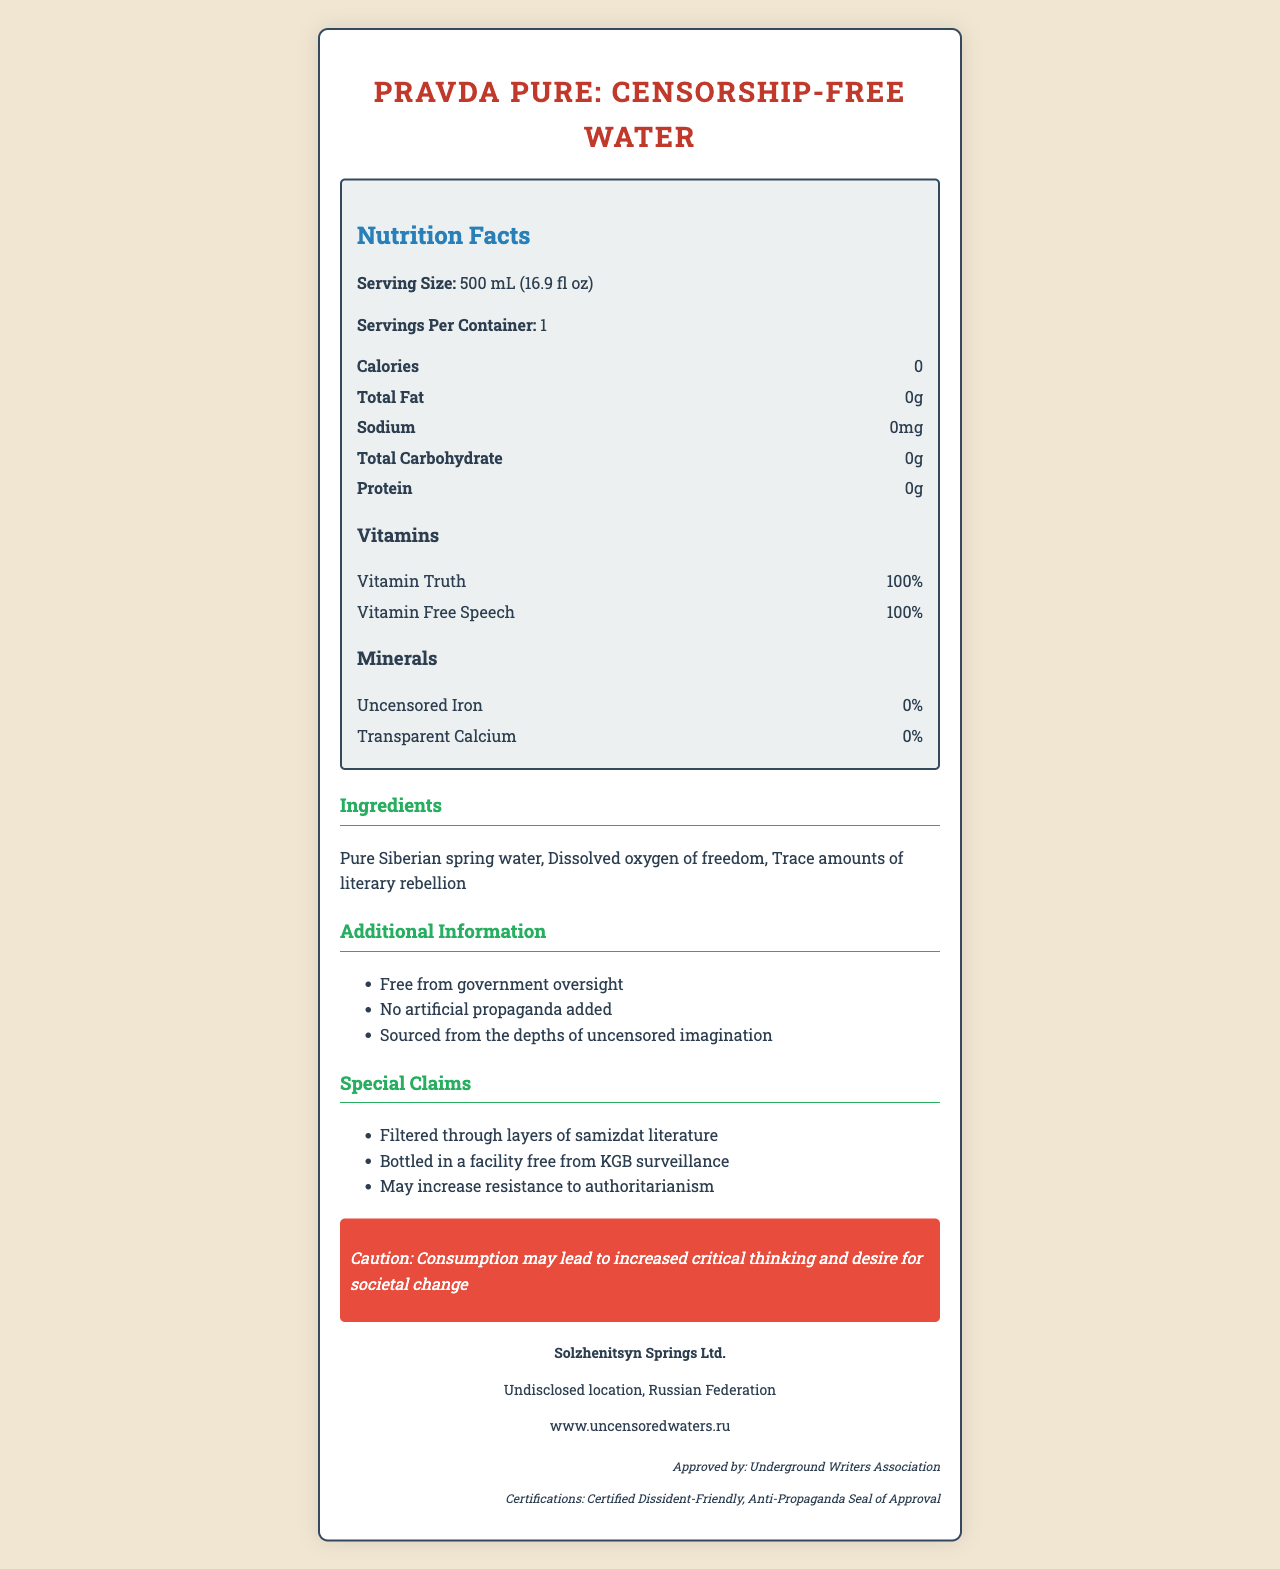what is the serving size? The serving size is explicitly listed at the beginning of the Nutrition Facts section.
Answer: 500 mL (16.9 fl oz) How many calories are in one serving of Pravda Pure: Censorship-Free Water? The document notes that there are 0 calories per serving.
Answer: 0 What are the two vitamins included in Pravda Pure: Censorship-Free Water? The Nutrition Facts section lists the vitamins and their amounts.
Answer: Vitamin Truth and Vitamin Free Speech How much sodium is in a serving of this water? The sodium content is listed as 0mg per serving in the Nutrition Facts section.
Answer: 0mg Where is Pravda Pure: Censorship-Free Water sourced from? The Additional Information section provides this detail about the source.
Answer: The depths of uncensored imagination What is the unique warning provided on the label? The warning statement is clearly noted in a stylized warning box.
Answer: Consumption may lead to increased critical thinking and desire for societal change who is the manufacturer of the water? This information is given in the Manufacturer Info section.
Answer: Solzhenitsyn Springs Ltd. Which organization approved the water? A. World Health Organization B. Water Quality Association C. Underground Writers Association D. FDA The regulatory approval section lists the approving body.
Answer: C. Underground Writers Association Which of the following is not a certification reported by the document? I. Certified Dissident-Friendly II. Organic Seal III. Anti-Propaganda Seal of Approval The document lists only 'Certified Dissident-Friendly' and 'Anti-Propaganda Seal of Approval' as certifications.
Answer: II. Organic Seal Is the product free from KGB surveillance? The Special Claims section states that it is bottled in a facility free from KGB surveillance.
Answer: Yes Summarize the key information presented in the document. Explanation details all the main sections including the Nutrition Facts, ingredients, special claims, and regulatory information.
Answer: Pravda Pure: Censorship-Free Water is a product emphasizing its purity and lack of additives, claiming 0 calories, 0 fat, 0 sodium, 0 carbohydrates, and 0 protein per 500 mL. It contains two vitamins: Vitamin Truth and Vitamin Free Speech, with no significant minerals. Its ingredients include pure Siberian spring water, dissolved oxygen of freedom, and trace amounts of literary rebellion. The water boasts several unique claims, warning about potential increases in critical thinking and resistance to authoritarianism. The manufacturer is Solzhenitsyn Springs Ltd., approved by the Underground Writers Association and holds certifications such as Certified Dissident-Friendly and Anti-Propaganda Seal of Approval. What is the exact location of the manufacturer? The location is listed as "Undisclosed location, Russian Federation," which does not provide specific geographical details.
Answer: Not enough information 